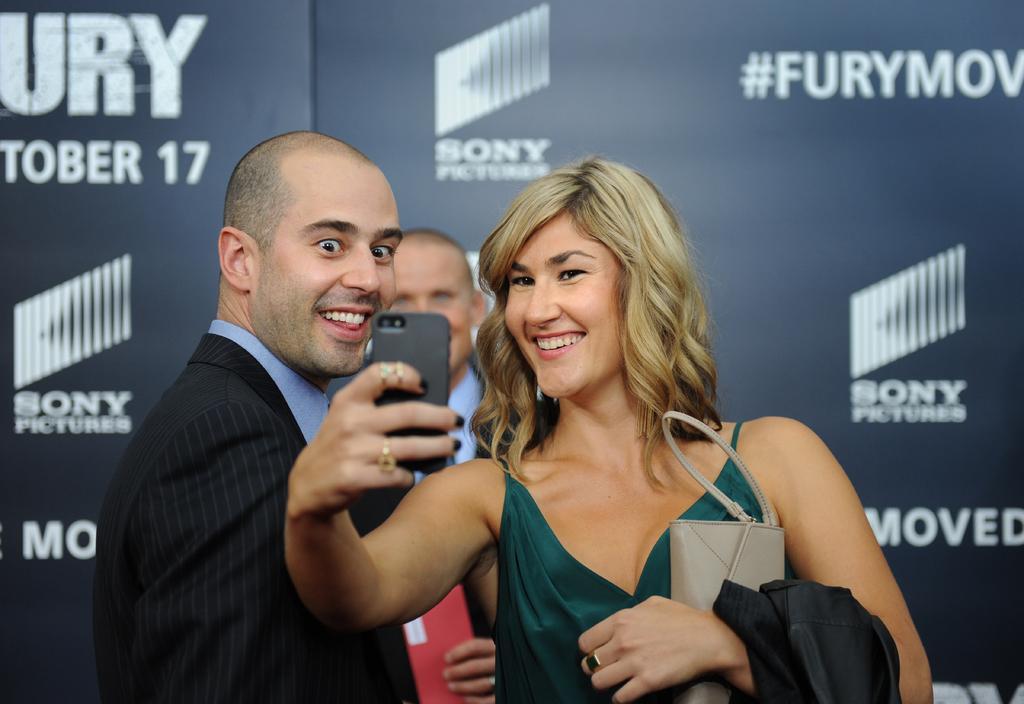How would you summarize this image in a sentence or two? In the center of the image we can see a lady standing and holding a mobile and a wallet in her hand, next to her there are two people. In the background we can see a board. 